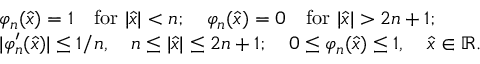<formula> <loc_0><loc_0><loc_500><loc_500>\begin{array} { r l } & { \varphi _ { n } ( \widehat { x } ) = 1 \quad f o r | \widehat { x } | < n ; \quad \varphi _ { n } ( \widehat { x } ) = 0 \quad f o r | \widehat { x } | > 2 n + 1 ; } \\ & { | \varphi _ { n } ^ { \prime } ( \widehat { x } ) | \leq 1 / n , \quad n \leq | \widehat { x } | \leq 2 n + 1 ; \quad 0 \leq \varphi _ { n } ( \widehat { x } ) \leq 1 , \quad \widehat { x } \in { \mathbb { R } } . } \end{array}</formula> 